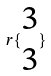<formula> <loc_0><loc_0><loc_500><loc_500>r \{ \begin{matrix} 3 \\ 3 \end{matrix} \}</formula> 